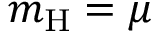<formula> <loc_0><loc_0><loc_500><loc_500>m _ { H } = \mu</formula> 